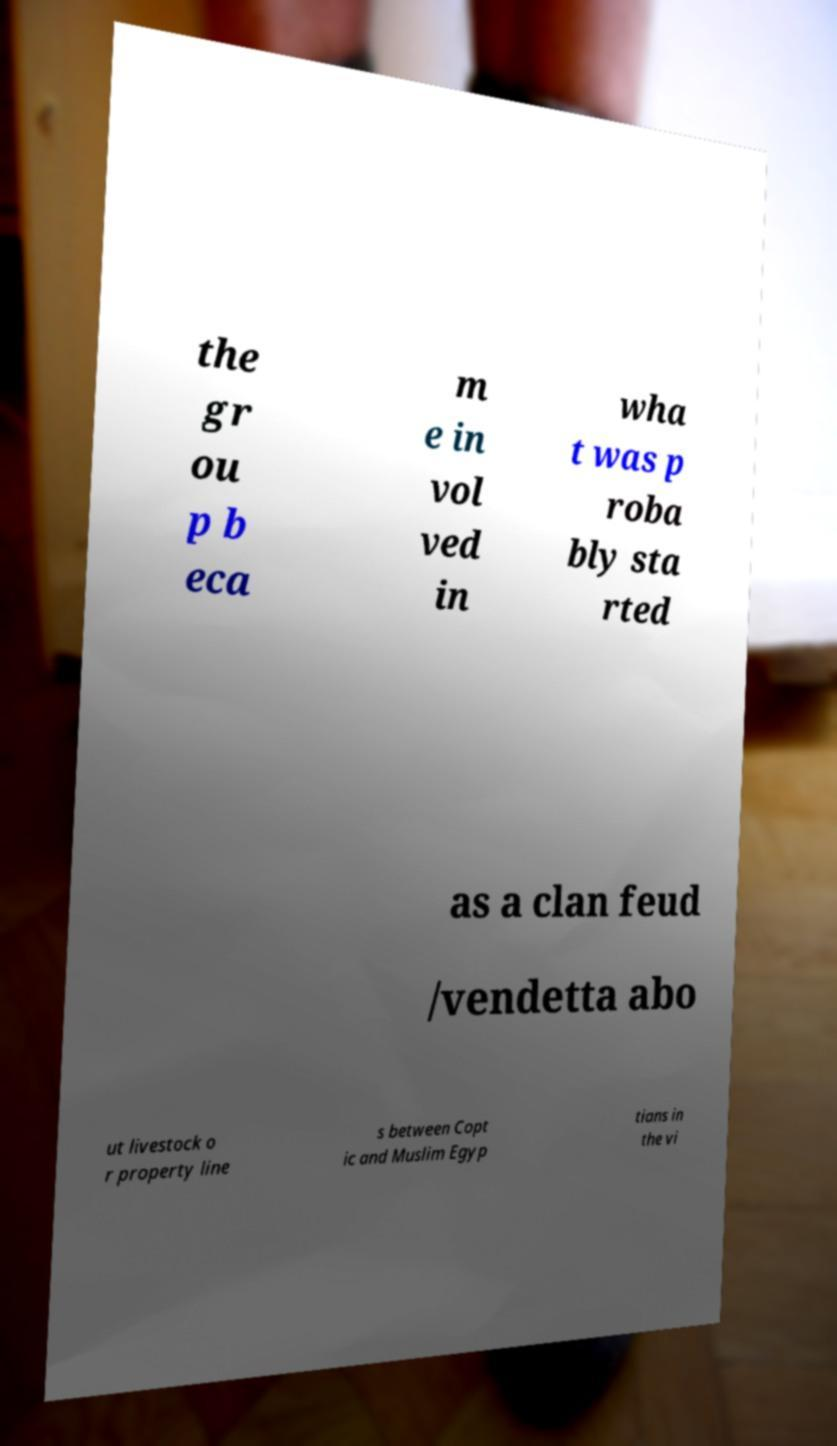Could you assist in decoding the text presented in this image and type it out clearly? the gr ou p b eca m e in vol ved in wha t was p roba bly sta rted as a clan feud /vendetta abo ut livestock o r property line s between Copt ic and Muslim Egyp tians in the vi 